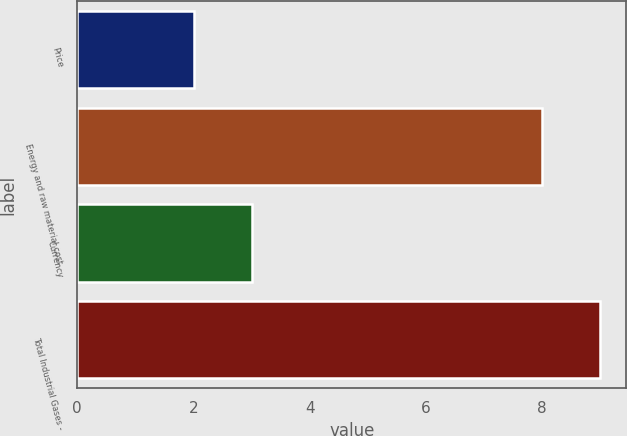Convert chart to OTSL. <chart><loc_0><loc_0><loc_500><loc_500><bar_chart><fcel>Price<fcel>Energy and raw material cost<fcel>Currency<fcel>Total Industrial Gases -<nl><fcel>2<fcel>8<fcel>3<fcel>9<nl></chart> 